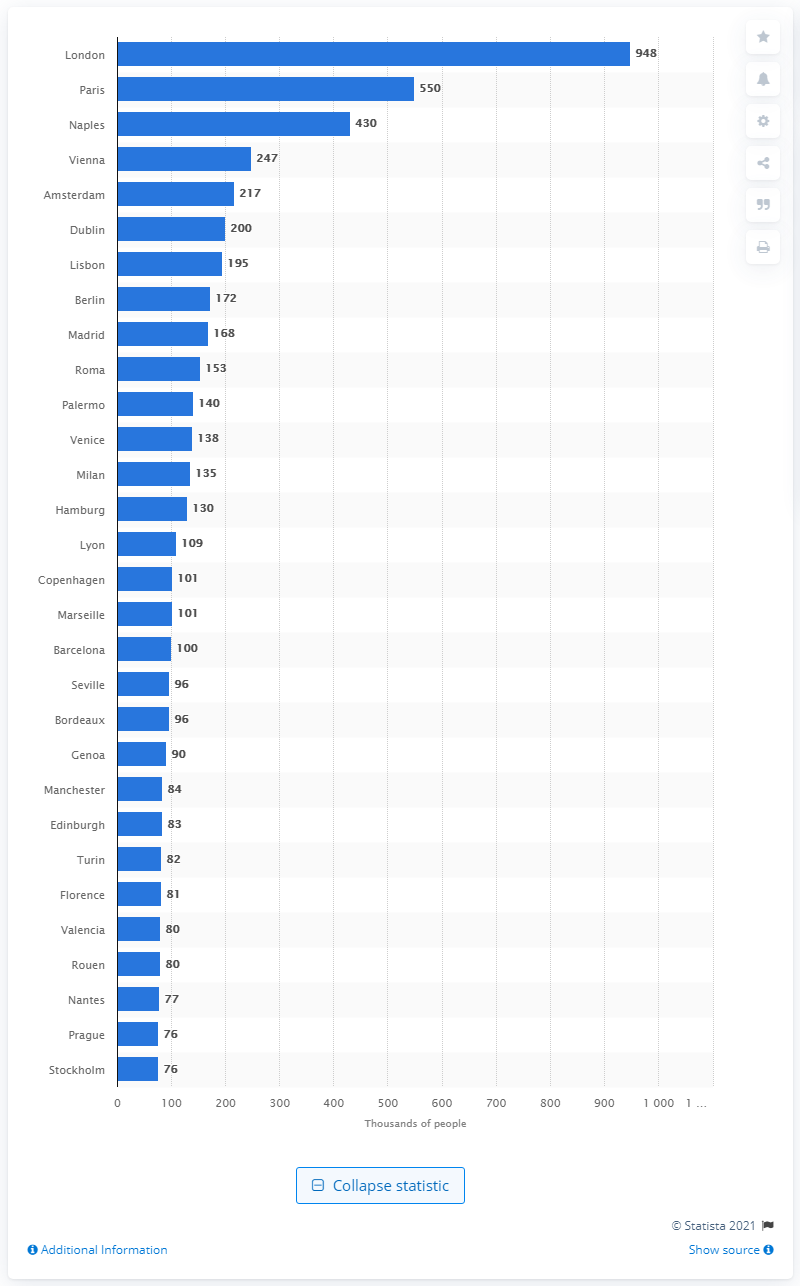What factors could explain why London had such a large population compared to other cities at the time? London's population growth can be attributed to several key factors. As the Industrial Revolution took hold, London became a center for manufacturing and trade, drawing people from rural areas seeking employment and better living standards. Additionally, London's status as the capital of the British Empire facilitated the influx of wealth, resources, and people from across the globe, further boosting its population. Technological advancements in transportation and infrastructure, including the development of railways and the Thames River as a trade artery, also supported the city's rapid expansion. 